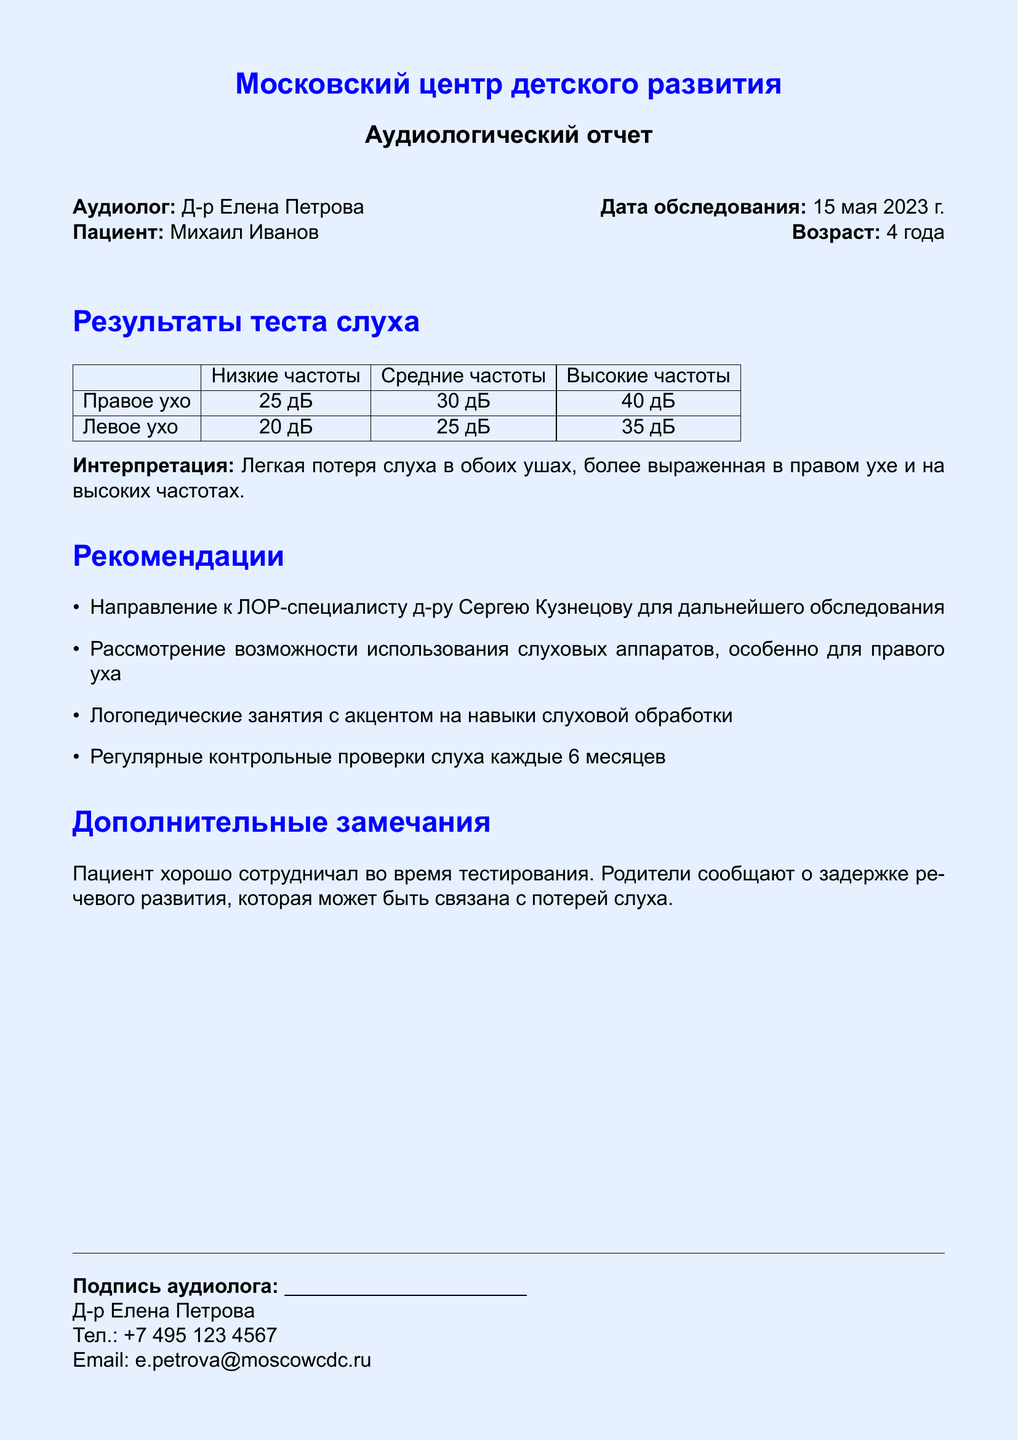Что за обследование проведено? Обследование слуха проведено аудиологом для оценки слуха пациента.
Answer: Слух Кто является аудиологом? Аудиолог указанный в документе - это специалист, который проводил тест.
Answer: Д-р Елена Петрова Каков возраст пациента? Возраст пациента - это информация, указанная в начале документа.
Answer: 4 года Что показали результаты теста слуха для правого уха на высоких частотах? Результаты для правого уха на высоких частотах подробно указаны в таблице.
Answer: 40 дБ Какие рекомендации даны для дальнейшего обследования? Рекомендации в документе перечислены в пунктах, касающихся последующих действий.
Answer: Направление к ЛОР-специалисту Какое дополнительное замечание сделано об уровне сотрудничества пациента? Дополнительные замечания включают оценку взаимодействия пациента во время тестирования.
Answer: Пациент хорошо сотрудничал Сколько раз в год рекомендуется проводить контрольные проверки слуха? Рекомендации включают частоту контрольных проверок в зависимости от состояния пациента.
Answer: Каждые 6 месяцев Что сообщают родители о речи пациента? Информация о речевом развитии пациента предоставлена родителями в документе.
Answer: Задержка речевого развития 